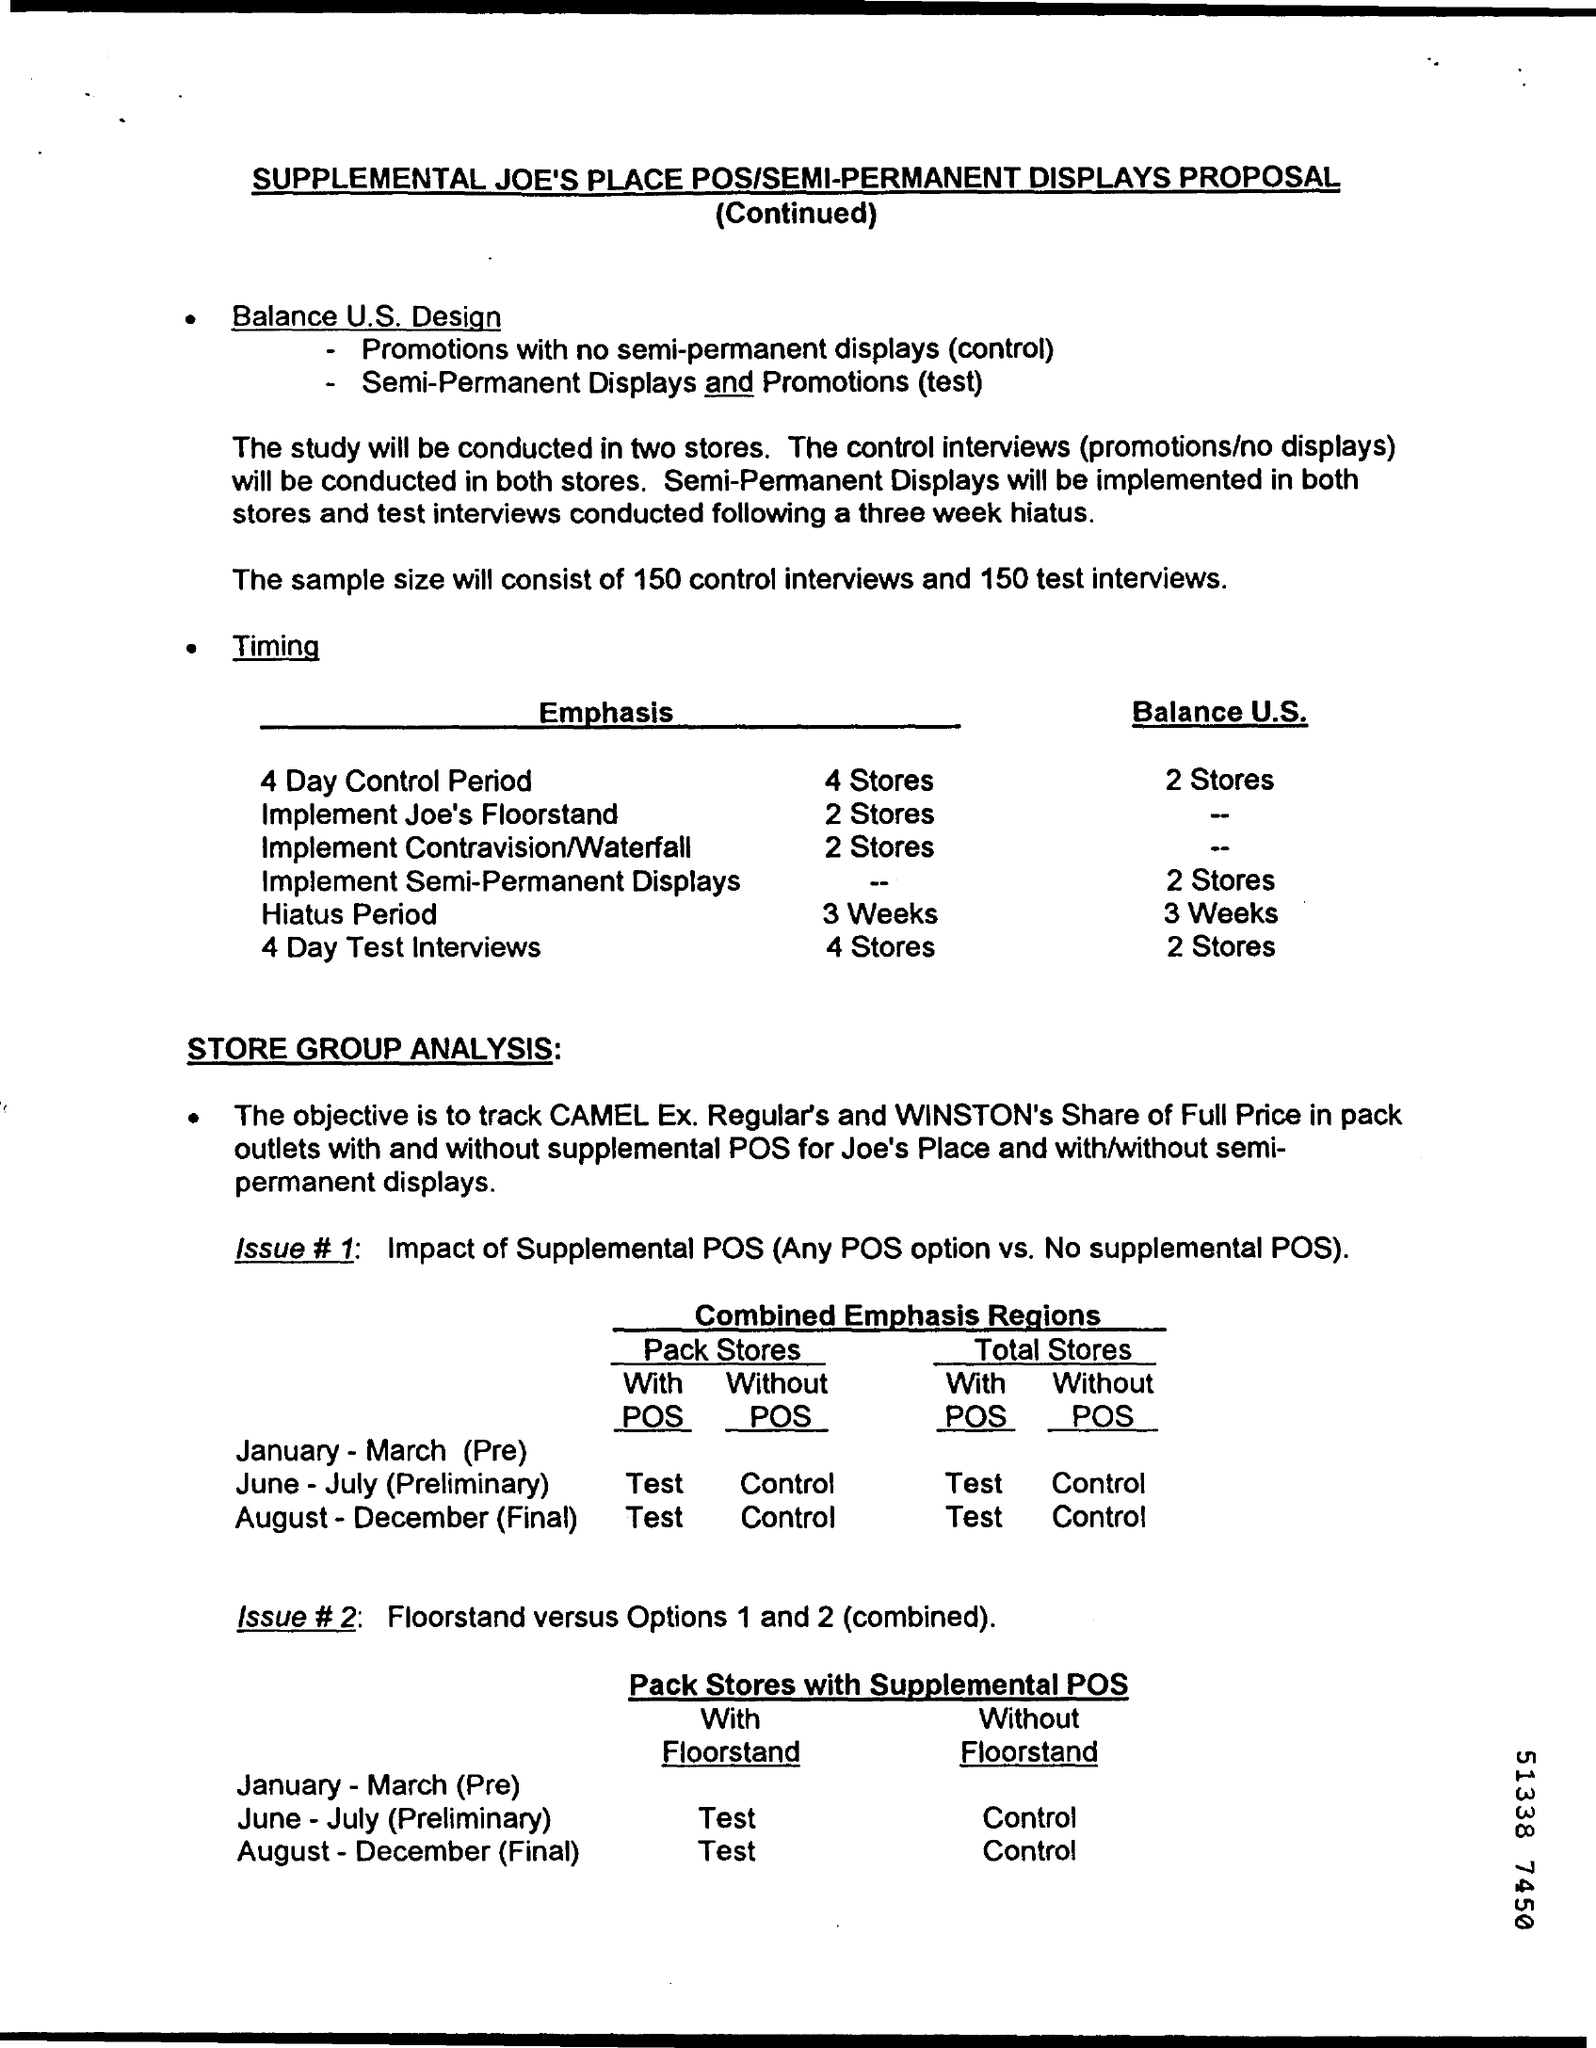How many Control Interviews will the Sample size have?
Give a very brief answer. 150. How many test Interviews will the Sample size have?
Your answer should be very brief. 150. 